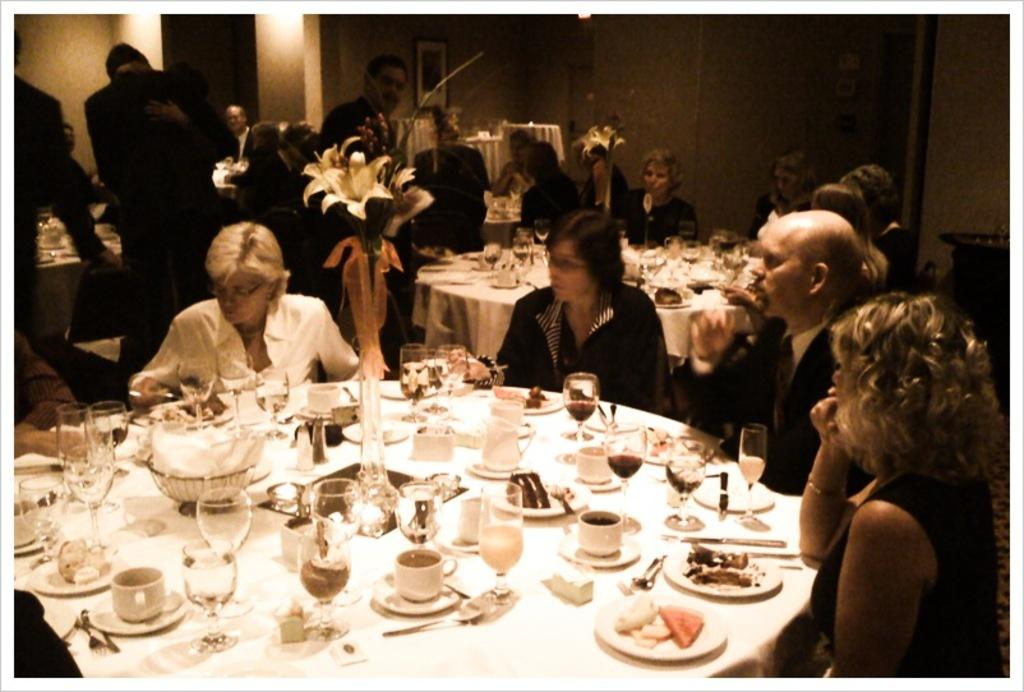How many tables are visible in the image? There are three tables in the image. What is covering each table? Each table has a white color cloth on it. What types of tableware can be seen on the tables? There are cups, saucers, glasses, and a flask on the tables. Are there any people present in the image? Yes, there are three people standing near the tables. Can you see any goldfish swimming in the cups on the tables? There are no goldfish present in the image; only cups, saucers, glasses, and a flask can be seen on the tables. 